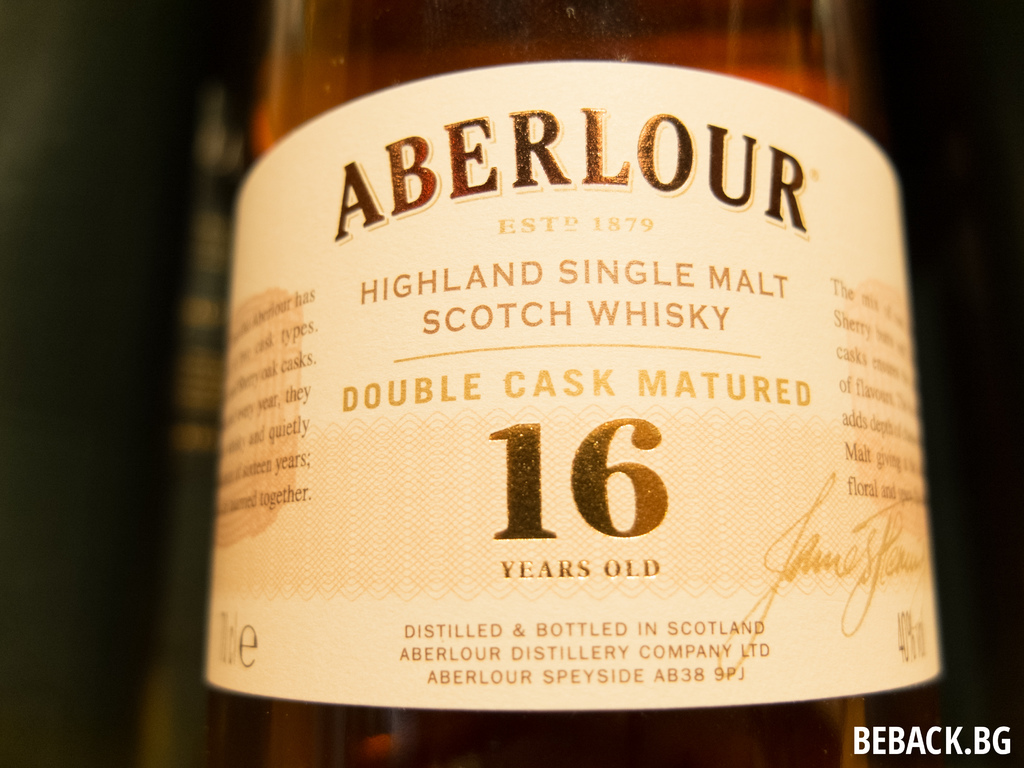Provide a one-sentence caption for the provided image. This image displays a bottle of Aberlour 16-year-old Highland Single Malt Scotch Whisky, noted for its double cask maturation process which enriches its flavor profile, distilled and bottled by the Aberlour Distillery Company in Speyside, Scotland, established in 1879. 